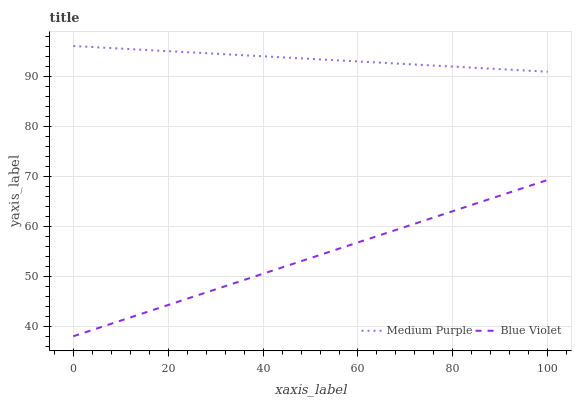Does Blue Violet have the minimum area under the curve?
Answer yes or no. Yes. Does Medium Purple have the maximum area under the curve?
Answer yes or no. Yes. Does Blue Violet have the maximum area under the curve?
Answer yes or no. No. Is Blue Violet the smoothest?
Answer yes or no. Yes. Is Medium Purple the roughest?
Answer yes or no. Yes. Is Blue Violet the roughest?
Answer yes or no. No. Does Blue Violet have the lowest value?
Answer yes or no. Yes. Does Medium Purple have the highest value?
Answer yes or no. Yes. Does Blue Violet have the highest value?
Answer yes or no. No. Is Blue Violet less than Medium Purple?
Answer yes or no. Yes. Is Medium Purple greater than Blue Violet?
Answer yes or no. Yes. Does Blue Violet intersect Medium Purple?
Answer yes or no. No. 